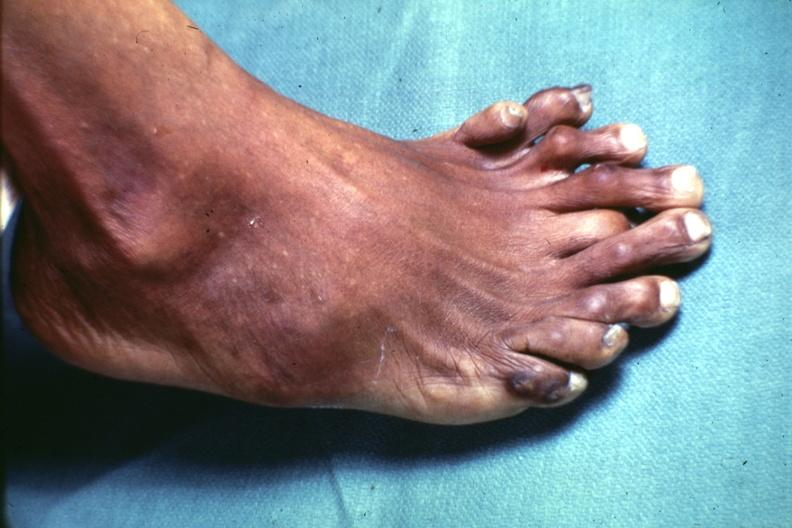s six digits present?
Answer the question using a single word or phrase. No 